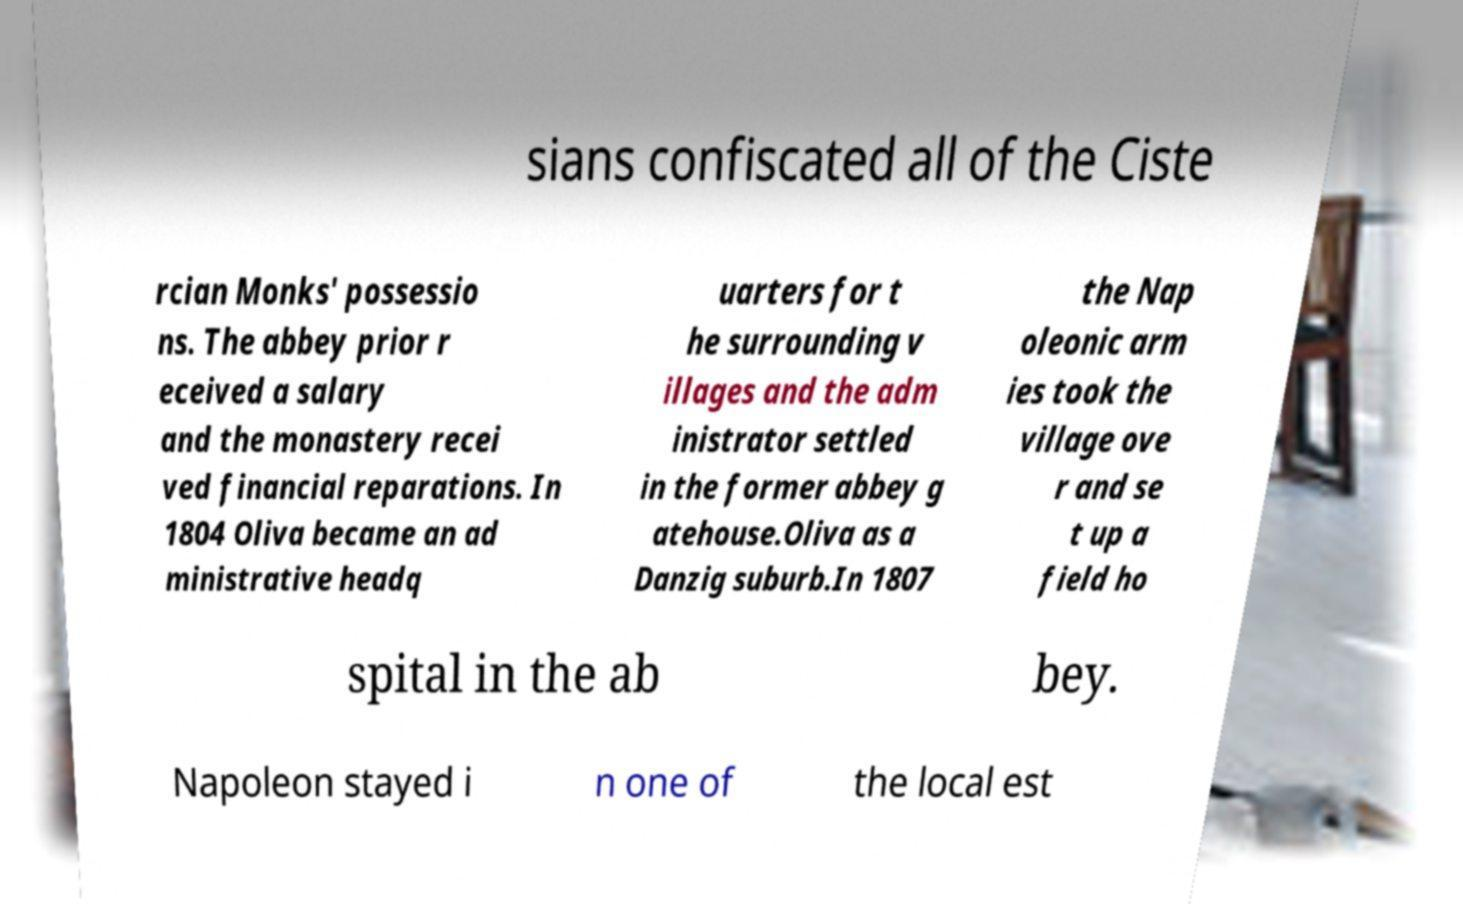For documentation purposes, I need the text within this image transcribed. Could you provide that? sians confiscated all of the Ciste rcian Monks' possessio ns. The abbey prior r eceived a salary and the monastery recei ved financial reparations. In 1804 Oliva became an ad ministrative headq uarters for t he surrounding v illages and the adm inistrator settled in the former abbey g atehouse.Oliva as a Danzig suburb.In 1807 the Nap oleonic arm ies took the village ove r and se t up a field ho spital in the ab bey. Napoleon stayed i n one of the local est 